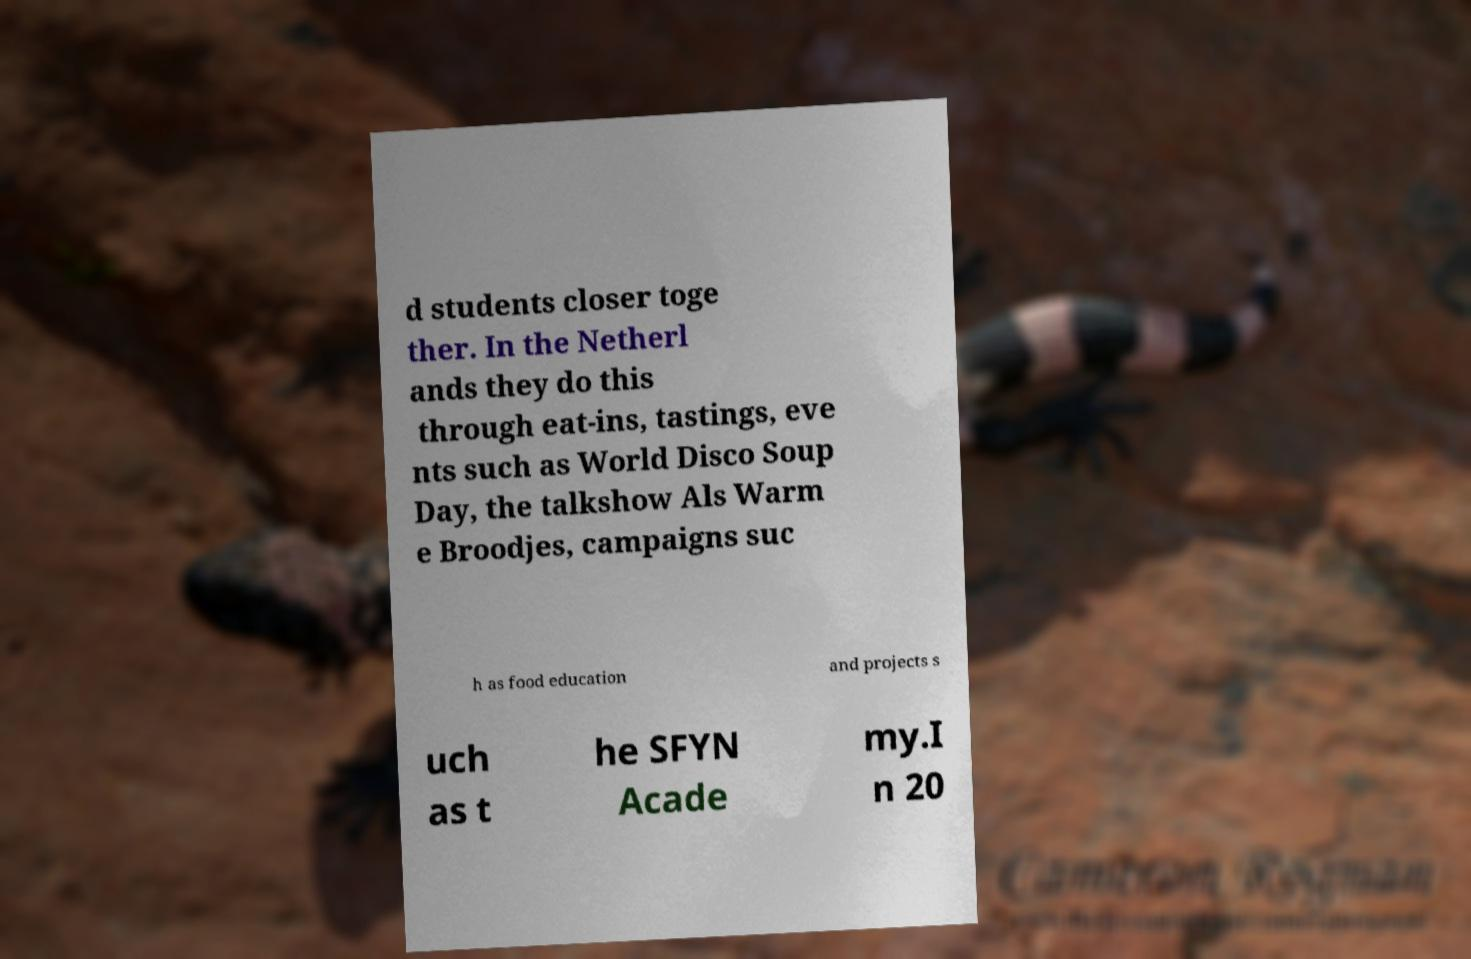There's text embedded in this image that I need extracted. Can you transcribe it verbatim? d students closer toge ther. In the Netherl ands they do this through eat-ins, tastings, eve nts such as World Disco Soup Day, the talkshow Als Warm e Broodjes, campaigns suc h as food education and projects s uch as t he SFYN Acade my.I n 20 